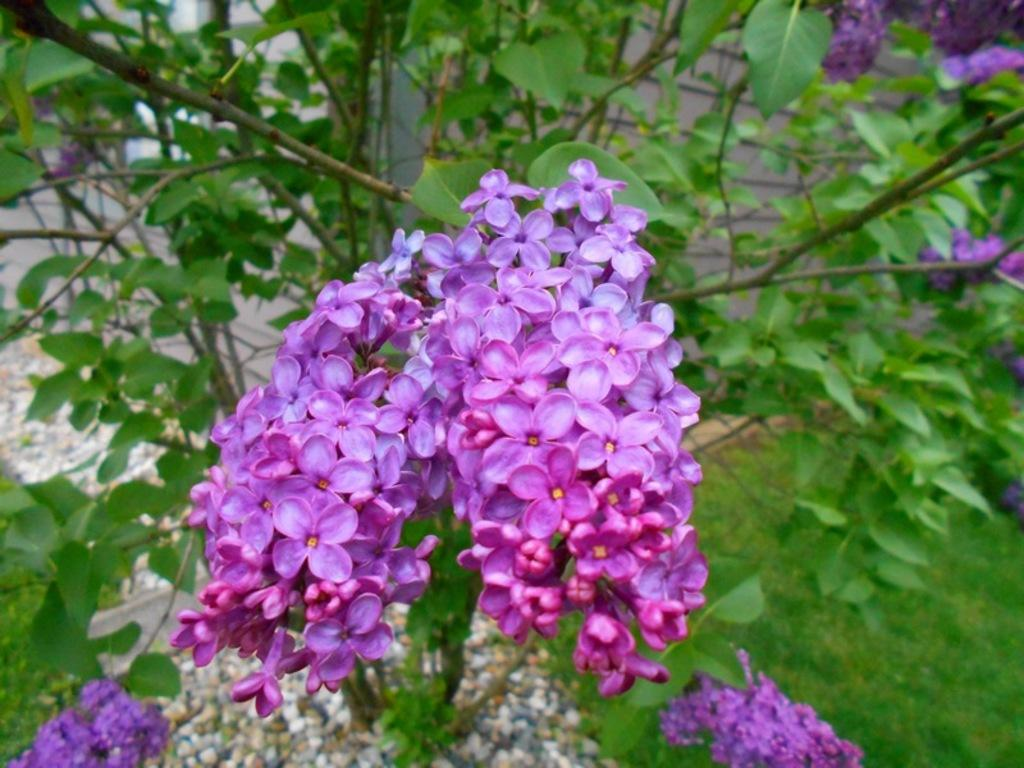What type of plants can be seen in the image? There are tiny flowers and leaves in the image. What else is present in the image besides plants? There are stones in the image. How can the flowers be folded in the image? The flowers cannot be folded in the image, as they are not real flowers but rather a representation of them. 